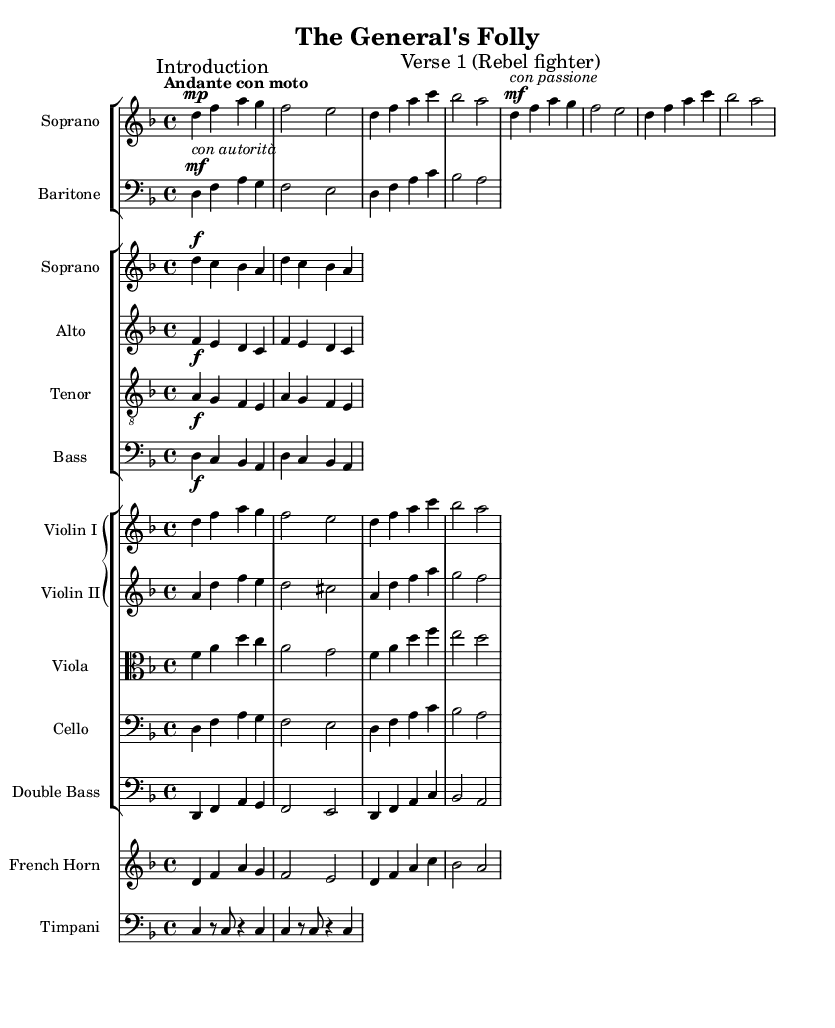What is the key signature of this music? The key signature is indicated in the global section as D minor, which has one flat (Bb).
Answer: D minor What is the time signature of this music? The time signature is presented in the global section as 4/4, which means there are four beats per measure.
Answer: 4/4 What is the tempo marking for this piece? The tempo is indicated in the global section as "Andante con moto," which suggests a moderately slow tempo with movement.
Answer: Andante con moto Which voice type has the marking "con passione"? The soprano voice contains the marking "con passione" in the vocal part, which translates to "with passion."
Answer: Soprano Which instruments accompany the vocal parts? The orchestration includes Violin I, Violin II, Viola, Cello, Double Bass, French Horn, and Timpani, which accompany the vocal parts throughout the piece.
Answer: Strings and horn How many vocal parts are featured in this opera section? The score includes four vocal parts: Soprano, Baritone, Alto, Tenor, and Bass, indicating five distinct vocal lines.
Answer: Five What is the dynamic marking at the start of the chorus? The chorus voices have the dynamic marking of "f," indicating a strong or loud sound should be produced by the choir.
Answer: f 